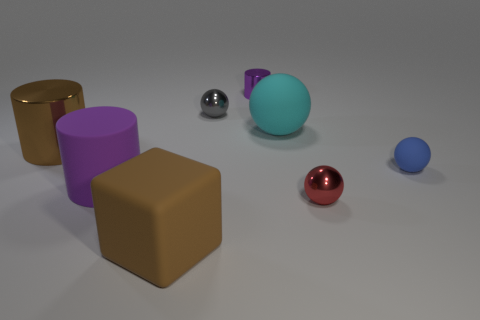There is a metallic cylinder that is in front of the large cyan thing; is its size the same as the metallic sphere in front of the purple rubber thing?
Your answer should be very brief. No. There is a ball that is in front of the small sphere on the right side of the red sphere; how big is it?
Ensure brevity in your answer.  Small. What is the size of the metallic thing that is both right of the gray ball and to the left of the big cyan ball?
Keep it short and to the point. Small. There is a cube that is the same color as the big metal cylinder; what size is it?
Offer a terse response. Large. What color is the large matte ball?
Your answer should be compact. Cyan. The object that is both on the left side of the cyan matte ball and in front of the matte cylinder is what color?
Keep it short and to the point. Brown. The metallic cylinder that is in front of the tiny sphere that is left of the small thing that is in front of the small matte sphere is what color?
Your answer should be very brief. Brown. There is another metal ball that is the same size as the red sphere; what is its color?
Offer a very short reply. Gray. There is a purple thing on the left side of the big rubber thing in front of the tiny shiny ball in front of the small gray thing; what shape is it?
Give a very brief answer. Cylinder. What is the shape of the metallic thing that is the same color as the block?
Make the answer very short. Cylinder. 